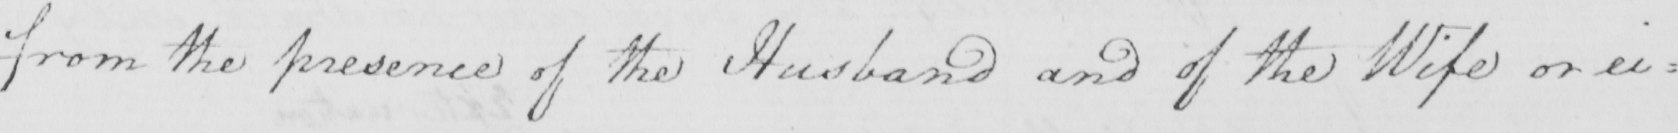Transcribe the text shown in this historical manuscript line. from the presence of the Husband and of the Wife or ei= 